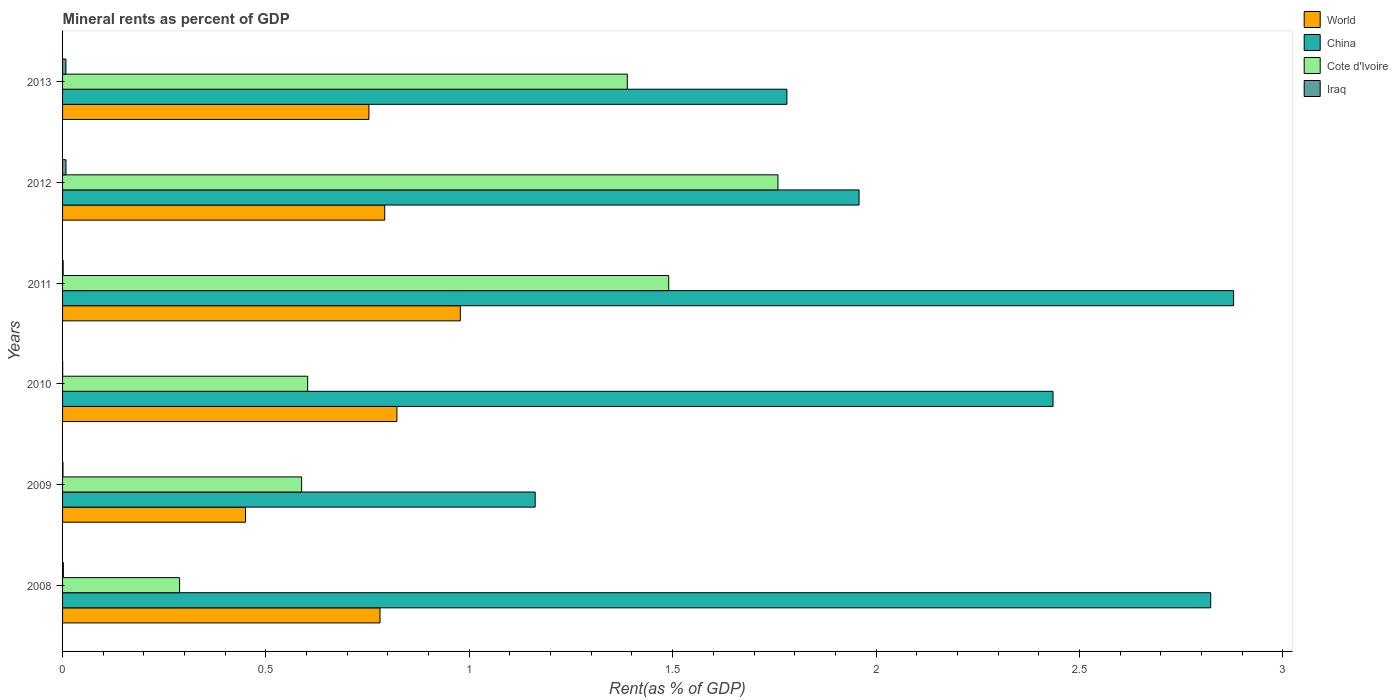What is the label of the 4th group of bars from the top?
Offer a terse response. 2010. In how many cases, is the number of bars for a given year not equal to the number of legend labels?
Provide a short and direct response. 0. What is the mineral rent in China in 2011?
Provide a succinct answer. 2.88. Across all years, what is the maximum mineral rent in Cote d'Ivoire?
Make the answer very short. 1.76. Across all years, what is the minimum mineral rent in Cote d'Ivoire?
Your answer should be compact. 0.29. In which year was the mineral rent in China maximum?
Keep it short and to the point. 2011. In which year was the mineral rent in China minimum?
Your response must be concise. 2009. What is the total mineral rent in Cote d'Ivoire in the graph?
Offer a terse response. 6.12. What is the difference between the mineral rent in China in 2010 and that in 2013?
Offer a very short reply. 0.65. What is the difference between the mineral rent in World in 2010 and the mineral rent in China in 2012?
Provide a succinct answer. -1.14. What is the average mineral rent in Cote d'Ivoire per year?
Provide a succinct answer. 1.02. In the year 2012, what is the difference between the mineral rent in World and mineral rent in Cote d'Ivoire?
Make the answer very short. -0.97. What is the ratio of the mineral rent in World in 2009 to that in 2010?
Provide a short and direct response. 0.55. What is the difference between the highest and the second highest mineral rent in World?
Give a very brief answer. 0.16. What is the difference between the highest and the lowest mineral rent in China?
Provide a short and direct response. 1.72. Is it the case that in every year, the sum of the mineral rent in World and mineral rent in China is greater than the sum of mineral rent in Iraq and mineral rent in Cote d'Ivoire?
Give a very brief answer. No. What does the 1st bar from the top in 2009 represents?
Offer a very short reply. Iraq. What does the 3rd bar from the bottom in 2010 represents?
Your answer should be compact. Cote d'Ivoire. Is it the case that in every year, the sum of the mineral rent in Cote d'Ivoire and mineral rent in World is greater than the mineral rent in Iraq?
Your answer should be compact. Yes. Are all the bars in the graph horizontal?
Ensure brevity in your answer.  Yes. How many years are there in the graph?
Ensure brevity in your answer.  6. Does the graph contain any zero values?
Give a very brief answer. No. Where does the legend appear in the graph?
Provide a short and direct response. Top right. How are the legend labels stacked?
Provide a succinct answer. Vertical. What is the title of the graph?
Ensure brevity in your answer.  Mineral rents as percent of GDP. Does "Pakistan" appear as one of the legend labels in the graph?
Keep it short and to the point. No. What is the label or title of the X-axis?
Ensure brevity in your answer.  Rent(as % of GDP). What is the label or title of the Y-axis?
Offer a very short reply. Years. What is the Rent(as % of GDP) in World in 2008?
Your response must be concise. 0.78. What is the Rent(as % of GDP) of China in 2008?
Ensure brevity in your answer.  2.82. What is the Rent(as % of GDP) in Cote d'Ivoire in 2008?
Ensure brevity in your answer.  0.29. What is the Rent(as % of GDP) of Iraq in 2008?
Ensure brevity in your answer.  0. What is the Rent(as % of GDP) of World in 2009?
Give a very brief answer. 0.45. What is the Rent(as % of GDP) of China in 2009?
Make the answer very short. 1.16. What is the Rent(as % of GDP) in Cote d'Ivoire in 2009?
Offer a terse response. 0.59. What is the Rent(as % of GDP) of Iraq in 2009?
Offer a very short reply. 0. What is the Rent(as % of GDP) of World in 2010?
Offer a very short reply. 0.82. What is the Rent(as % of GDP) of China in 2010?
Your response must be concise. 2.44. What is the Rent(as % of GDP) of Cote d'Ivoire in 2010?
Ensure brevity in your answer.  0.6. What is the Rent(as % of GDP) of Iraq in 2010?
Your response must be concise. 0. What is the Rent(as % of GDP) in World in 2011?
Your answer should be very brief. 0.98. What is the Rent(as % of GDP) in China in 2011?
Offer a terse response. 2.88. What is the Rent(as % of GDP) of Cote d'Ivoire in 2011?
Ensure brevity in your answer.  1.49. What is the Rent(as % of GDP) in Iraq in 2011?
Provide a short and direct response. 0. What is the Rent(as % of GDP) in World in 2012?
Ensure brevity in your answer.  0.79. What is the Rent(as % of GDP) in China in 2012?
Make the answer very short. 1.96. What is the Rent(as % of GDP) in Cote d'Ivoire in 2012?
Provide a succinct answer. 1.76. What is the Rent(as % of GDP) in Iraq in 2012?
Give a very brief answer. 0.01. What is the Rent(as % of GDP) in World in 2013?
Offer a terse response. 0.75. What is the Rent(as % of GDP) in China in 2013?
Provide a short and direct response. 1.78. What is the Rent(as % of GDP) in Cote d'Ivoire in 2013?
Your answer should be very brief. 1.39. What is the Rent(as % of GDP) of Iraq in 2013?
Keep it short and to the point. 0.01. Across all years, what is the maximum Rent(as % of GDP) in World?
Your answer should be very brief. 0.98. Across all years, what is the maximum Rent(as % of GDP) in China?
Offer a terse response. 2.88. Across all years, what is the maximum Rent(as % of GDP) of Cote d'Ivoire?
Provide a short and direct response. 1.76. Across all years, what is the maximum Rent(as % of GDP) in Iraq?
Offer a terse response. 0.01. Across all years, what is the minimum Rent(as % of GDP) in World?
Provide a short and direct response. 0.45. Across all years, what is the minimum Rent(as % of GDP) in China?
Make the answer very short. 1.16. Across all years, what is the minimum Rent(as % of GDP) of Cote d'Ivoire?
Offer a terse response. 0.29. Across all years, what is the minimum Rent(as % of GDP) of Iraq?
Your answer should be very brief. 0. What is the total Rent(as % of GDP) of World in the graph?
Keep it short and to the point. 4.58. What is the total Rent(as % of GDP) in China in the graph?
Your response must be concise. 13.04. What is the total Rent(as % of GDP) of Cote d'Ivoire in the graph?
Keep it short and to the point. 6.12. What is the total Rent(as % of GDP) in Iraq in the graph?
Make the answer very short. 0.02. What is the difference between the Rent(as % of GDP) of World in 2008 and that in 2009?
Keep it short and to the point. 0.33. What is the difference between the Rent(as % of GDP) in China in 2008 and that in 2009?
Keep it short and to the point. 1.66. What is the difference between the Rent(as % of GDP) of Iraq in 2008 and that in 2009?
Make the answer very short. 0. What is the difference between the Rent(as % of GDP) in World in 2008 and that in 2010?
Offer a very short reply. -0.04. What is the difference between the Rent(as % of GDP) of China in 2008 and that in 2010?
Provide a short and direct response. 0.39. What is the difference between the Rent(as % of GDP) of Cote d'Ivoire in 2008 and that in 2010?
Make the answer very short. -0.31. What is the difference between the Rent(as % of GDP) in Iraq in 2008 and that in 2010?
Make the answer very short. 0. What is the difference between the Rent(as % of GDP) of World in 2008 and that in 2011?
Keep it short and to the point. -0.2. What is the difference between the Rent(as % of GDP) in China in 2008 and that in 2011?
Your answer should be very brief. -0.06. What is the difference between the Rent(as % of GDP) of Cote d'Ivoire in 2008 and that in 2011?
Provide a short and direct response. -1.2. What is the difference between the Rent(as % of GDP) of World in 2008 and that in 2012?
Give a very brief answer. -0.01. What is the difference between the Rent(as % of GDP) in China in 2008 and that in 2012?
Give a very brief answer. 0.86. What is the difference between the Rent(as % of GDP) of Cote d'Ivoire in 2008 and that in 2012?
Provide a short and direct response. -1.47. What is the difference between the Rent(as % of GDP) in Iraq in 2008 and that in 2012?
Give a very brief answer. -0.01. What is the difference between the Rent(as % of GDP) of World in 2008 and that in 2013?
Offer a very short reply. 0.03. What is the difference between the Rent(as % of GDP) of China in 2008 and that in 2013?
Offer a very short reply. 1.04. What is the difference between the Rent(as % of GDP) of Cote d'Ivoire in 2008 and that in 2013?
Your response must be concise. -1.1. What is the difference between the Rent(as % of GDP) of Iraq in 2008 and that in 2013?
Offer a very short reply. -0.01. What is the difference between the Rent(as % of GDP) of World in 2009 and that in 2010?
Provide a succinct answer. -0.37. What is the difference between the Rent(as % of GDP) of China in 2009 and that in 2010?
Your answer should be very brief. -1.27. What is the difference between the Rent(as % of GDP) of Cote d'Ivoire in 2009 and that in 2010?
Keep it short and to the point. -0.01. What is the difference between the Rent(as % of GDP) of Iraq in 2009 and that in 2010?
Offer a terse response. 0. What is the difference between the Rent(as % of GDP) in World in 2009 and that in 2011?
Keep it short and to the point. -0.53. What is the difference between the Rent(as % of GDP) in China in 2009 and that in 2011?
Your answer should be very brief. -1.72. What is the difference between the Rent(as % of GDP) of Cote d'Ivoire in 2009 and that in 2011?
Your response must be concise. -0.9. What is the difference between the Rent(as % of GDP) in Iraq in 2009 and that in 2011?
Ensure brevity in your answer.  -0. What is the difference between the Rent(as % of GDP) of World in 2009 and that in 2012?
Make the answer very short. -0.34. What is the difference between the Rent(as % of GDP) of China in 2009 and that in 2012?
Give a very brief answer. -0.8. What is the difference between the Rent(as % of GDP) in Cote d'Ivoire in 2009 and that in 2012?
Make the answer very short. -1.17. What is the difference between the Rent(as % of GDP) in Iraq in 2009 and that in 2012?
Offer a very short reply. -0.01. What is the difference between the Rent(as % of GDP) in World in 2009 and that in 2013?
Provide a short and direct response. -0.3. What is the difference between the Rent(as % of GDP) in China in 2009 and that in 2013?
Your response must be concise. -0.62. What is the difference between the Rent(as % of GDP) in Cote d'Ivoire in 2009 and that in 2013?
Ensure brevity in your answer.  -0.8. What is the difference between the Rent(as % of GDP) of Iraq in 2009 and that in 2013?
Your response must be concise. -0.01. What is the difference between the Rent(as % of GDP) in World in 2010 and that in 2011?
Ensure brevity in your answer.  -0.16. What is the difference between the Rent(as % of GDP) of China in 2010 and that in 2011?
Your answer should be very brief. -0.44. What is the difference between the Rent(as % of GDP) in Cote d'Ivoire in 2010 and that in 2011?
Give a very brief answer. -0.89. What is the difference between the Rent(as % of GDP) of Iraq in 2010 and that in 2011?
Keep it short and to the point. -0. What is the difference between the Rent(as % of GDP) in China in 2010 and that in 2012?
Offer a very short reply. 0.48. What is the difference between the Rent(as % of GDP) of Cote d'Ivoire in 2010 and that in 2012?
Keep it short and to the point. -1.16. What is the difference between the Rent(as % of GDP) of Iraq in 2010 and that in 2012?
Keep it short and to the point. -0.01. What is the difference between the Rent(as % of GDP) of World in 2010 and that in 2013?
Provide a succinct answer. 0.07. What is the difference between the Rent(as % of GDP) of China in 2010 and that in 2013?
Your answer should be very brief. 0.65. What is the difference between the Rent(as % of GDP) in Cote d'Ivoire in 2010 and that in 2013?
Offer a very short reply. -0.79. What is the difference between the Rent(as % of GDP) of Iraq in 2010 and that in 2013?
Your answer should be very brief. -0.01. What is the difference between the Rent(as % of GDP) of World in 2011 and that in 2012?
Give a very brief answer. 0.19. What is the difference between the Rent(as % of GDP) in China in 2011 and that in 2012?
Give a very brief answer. 0.92. What is the difference between the Rent(as % of GDP) in Cote d'Ivoire in 2011 and that in 2012?
Your response must be concise. -0.27. What is the difference between the Rent(as % of GDP) of Iraq in 2011 and that in 2012?
Ensure brevity in your answer.  -0.01. What is the difference between the Rent(as % of GDP) of World in 2011 and that in 2013?
Your answer should be very brief. 0.22. What is the difference between the Rent(as % of GDP) in China in 2011 and that in 2013?
Ensure brevity in your answer.  1.1. What is the difference between the Rent(as % of GDP) of Cote d'Ivoire in 2011 and that in 2013?
Offer a terse response. 0.1. What is the difference between the Rent(as % of GDP) in Iraq in 2011 and that in 2013?
Make the answer very short. -0.01. What is the difference between the Rent(as % of GDP) in World in 2012 and that in 2013?
Your answer should be compact. 0.04. What is the difference between the Rent(as % of GDP) in China in 2012 and that in 2013?
Your answer should be compact. 0.18. What is the difference between the Rent(as % of GDP) of Cote d'Ivoire in 2012 and that in 2013?
Make the answer very short. 0.37. What is the difference between the Rent(as % of GDP) of World in 2008 and the Rent(as % of GDP) of China in 2009?
Your answer should be very brief. -0.38. What is the difference between the Rent(as % of GDP) in World in 2008 and the Rent(as % of GDP) in Cote d'Ivoire in 2009?
Offer a very short reply. 0.19. What is the difference between the Rent(as % of GDP) of World in 2008 and the Rent(as % of GDP) of Iraq in 2009?
Keep it short and to the point. 0.78. What is the difference between the Rent(as % of GDP) of China in 2008 and the Rent(as % of GDP) of Cote d'Ivoire in 2009?
Provide a short and direct response. 2.24. What is the difference between the Rent(as % of GDP) in China in 2008 and the Rent(as % of GDP) in Iraq in 2009?
Make the answer very short. 2.82. What is the difference between the Rent(as % of GDP) of Cote d'Ivoire in 2008 and the Rent(as % of GDP) of Iraq in 2009?
Your answer should be compact. 0.29. What is the difference between the Rent(as % of GDP) in World in 2008 and the Rent(as % of GDP) in China in 2010?
Your answer should be compact. -1.65. What is the difference between the Rent(as % of GDP) in World in 2008 and the Rent(as % of GDP) in Cote d'Ivoire in 2010?
Your answer should be very brief. 0.18. What is the difference between the Rent(as % of GDP) of World in 2008 and the Rent(as % of GDP) of Iraq in 2010?
Your answer should be compact. 0.78. What is the difference between the Rent(as % of GDP) of China in 2008 and the Rent(as % of GDP) of Cote d'Ivoire in 2010?
Make the answer very short. 2.22. What is the difference between the Rent(as % of GDP) in China in 2008 and the Rent(as % of GDP) in Iraq in 2010?
Your response must be concise. 2.82. What is the difference between the Rent(as % of GDP) of Cote d'Ivoire in 2008 and the Rent(as % of GDP) of Iraq in 2010?
Provide a succinct answer. 0.29. What is the difference between the Rent(as % of GDP) in World in 2008 and the Rent(as % of GDP) in China in 2011?
Give a very brief answer. -2.1. What is the difference between the Rent(as % of GDP) of World in 2008 and the Rent(as % of GDP) of Cote d'Ivoire in 2011?
Offer a very short reply. -0.71. What is the difference between the Rent(as % of GDP) in World in 2008 and the Rent(as % of GDP) in Iraq in 2011?
Provide a short and direct response. 0.78. What is the difference between the Rent(as % of GDP) of China in 2008 and the Rent(as % of GDP) of Cote d'Ivoire in 2011?
Your answer should be compact. 1.33. What is the difference between the Rent(as % of GDP) of China in 2008 and the Rent(as % of GDP) of Iraq in 2011?
Your response must be concise. 2.82. What is the difference between the Rent(as % of GDP) in Cote d'Ivoire in 2008 and the Rent(as % of GDP) in Iraq in 2011?
Offer a terse response. 0.29. What is the difference between the Rent(as % of GDP) in World in 2008 and the Rent(as % of GDP) in China in 2012?
Ensure brevity in your answer.  -1.18. What is the difference between the Rent(as % of GDP) of World in 2008 and the Rent(as % of GDP) of Cote d'Ivoire in 2012?
Your answer should be compact. -0.98. What is the difference between the Rent(as % of GDP) of World in 2008 and the Rent(as % of GDP) of Iraq in 2012?
Make the answer very short. 0.77. What is the difference between the Rent(as % of GDP) in China in 2008 and the Rent(as % of GDP) in Cote d'Ivoire in 2012?
Offer a very short reply. 1.06. What is the difference between the Rent(as % of GDP) in China in 2008 and the Rent(as % of GDP) in Iraq in 2012?
Your response must be concise. 2.81. What is the difference between the Rent(as % of GDP) of Cote d'Ivoire in 2008 and the Rent(as % of GDP) of Iraq in 2012?
Make the answer very short. 0.28. What is the difference between the Rent(as % of GDP) of World in 2008 and the Rent(as % of GDP) of China in 2013?
Provide a succinct answer. -1. What is the difference between the Rent(as % of GDP) of World in 2008 and the Rent(as % of GDP) of Cote d'Ivoire in 2013?
Your answer should be very brief. -0.61. What is the difference between the Rent(as % of GDP) of World in 2008 and the Rent(as % of GDP) of Iraq in 2013?
Make the answer very short. 0.77. What is the difference between the Rent(as % of GDP) in China in 2008 and the Rent(as % of GDP) in Cote d'Ivoire in 2013?
Provide a succinct answer. 1.43. What is the difference between the Rent(as % of GDP) in China in 2008 and the Rent(as % of GDP) in Iraq in 2013?
Ensure brevity in your answer.  2.81. What is the difference between the Rent(as % of GDP) in Cote d'Ivoire in 2008 and the Rent(as % of GDP) in Iraq in 2013?
Offer a very short reply. 0.28. What is the difference between the Rent(as % of GDP) in World in 2009 and the Rent(as % of GDP) in China in 2010?
Offer a very short reply. -1.99. What is the difference between the Rent(as % of GDP) in World in 2009 and the Rent(as % of GDP) in Cote d'Ivoire in 2010?
Offer a very short reply. -0.15. What is the difference between the Rent(as % of GDP) in World in 2009 and the Rent(as % of GDP) in Iraq in 2010?
Offer a very short reply. 0.45. What is the difference between the Rent(as % of GDP) in China in 2009 and the Rent(as % of GDP) in Cote d'Ivoire in 2010?
Provide a short and direct response. 0.56. What is the difference between the Rent(as % of GDP) in China in 2009 and the Rent(as % of GDP) in Iraq in 2010?
Your response must be concise. 1.16. What is the difference between the Rent(as % of GDP) of Cote d'Ivoire in 2009 and the Rent(as % of GDP) of Iraq in 2010?
Offer a very short reply. 0.59. What is the difference between the Rent(as % of GDP) of World in 2009 and the Rent(as % of GDP) of China in 2011?
Ensure brevity in your answer.  -2.43. What is the difference between the Rent(as % of GDP) in World in 2009 and the Rent(as % of GDP) in Cote d'Ivoire in 2011?
Your answer should be very brief. -1.04. What is the difference between the Rent(as % of GDP) of World in 2009 and the Rent(as % of GDP) of Iraq in 2011?
Provide a short and direct response. 0.45. What is the difference between the Rent(as % of GDP) of China in 2009 and the Rent(as % of GDP) of Cote d'Ivoire in 2011?
Provide a succinct answer. -0.33. What is the difference between the Rent(as % of GDP) in China in 2009 and the Rent(as % of GDP) in Iraq in 2011?
Make the answer very short. 1.16. What is the difference between the Rent(as % of GDP) in Cote d'Ivoire in 2009 and the Rent(as % of GDP) in Iraq in 2011?
Offer a very short reply. 0.59. What is the difference between the Rent(as % of GDP) in World in 2009 and the Rent(as % of GDP) in China in 2012?
Your answer should be compact. -1.51. What is the difference between the Rent(as % of GDP) of World in 2009 and the Rent(as % of GDP) of Cote d'Ivoire in 2012?
Ensure brevity in your answer.  -1.31. What is the difference between the Rent(as % of GDP) in World in 2009 and the Rent(as % of GDP) in Iraq in 2012?
Offer a terse response. 0.44. What is the difference between the Rent(as % of GDP) in China in 2009 and the Rent(as % of GDP) in Cote d'Ivoire in 2012?
Provide a short and direct response. -0.6. What is the difference between the Rent(as % of GDP) in China in 2009 and the Rent(as % of GDP) in Iraq in 2012?
Ensure brevity in your answer.  1.15. What is the difference between the Rent(as % of GDP) of Cote d'Ivoire in 2009 and the Rent(as % of GDP) of Iraq in 2012?
Your answer should be compact. 0.58. What is the difference between the Rent(as % of GDP) in World in 2009 and the Rent(as % of GDP) in China in 2013?
Your answer should be compact. -1.33. What is the difference between the Rent(as % of GDP) in World in 2009 and the Rent(as % of GDP) in Cote d'Ivoire in 2013?
Your answer should be very brief. -0.94. What is the difference between the Rent(as % of GDP) in World in 2009 and the Rent(as % of GDP) in Iraq in 2013?
Offer a terse response. 0.44. What is the difference between the Rent(as % of GDP) in China in 2009 and the Rent(as % of GDP) in Cote d'Ivoire in 2013?
Provide a short and direct response. -0.23. What is the difference between the Rent(as % of GDP) in China in 2009 and the Rent(as % of GDP) in Iraq in 2013?
Your response must be concise. 1.15. What is the difference between the Rent(as % of GDP) in Cote d'Ivoire in 2009 and the Rent(as % of GDP) in Iraq in 2013?
Provide a succinct answer. 0.58. What is the difference between the Rent(as % of GDP) in World in 2010 and the Rent(as % of GDP) in China in 2011?
Your answer should be compact. -2.06. What is the difference between the Rent(as % of GDP) of World in 2010 and the Rent(as % of GDP) of Cote d'Ivoire in 2011?
Provide a short and direct response. -0.67. What is the difference between the Rent(as % of GDP) of World in 2010 and the Rent(as % of GDP) of Iraq in 2011?
Keep it short and to the point. 0.82. What is the difference between the Rent(as % of GDP) of China in 2010 and the Rent(as % of GDP) of Cote d'Ivoire in 2011?
Your answer should be very brief. 0.94. What is the difference between the Rent(as % of GDP) of China in 2010 and the Rent(as % of GDP) of Iraq in 2011?
Ensure brevity in your answer.  2.43. What is the difference between the Rent(as % of GDP) in Cote d'Ivoire in 2010 and the Rent(as % of GDP) in Iraq in 2011?
Offer a terse response. 0.6. What is the difference between the Rent(as % of GDP) in World in 2010 and the Rent(as % of GDP) in China in 2012?
Provide a short and direct response. -1.14. What is the difference between the Rent(as % of GDP) of World in 2010 and the Rent(as % of GDP) of Cote d'Ivoire in 2012?
Your response must be concise. -0.94. What is the difference between the Rent(as % of GDP) of World in 2010 and the Rent(as % of GDP) of Iraq in 2012?
Your response must be concise. 0.81. What is the difference between the Rent(as % of GDP) in China in 2010 and the Rent(as % of GDP) in Cote d'Ivoire in 2012?
Ensure brevity in your answer.  0.68. What is the difference between the Rent(as % of GDP) in China in 2010 and the Rent(as % of GDP) in Iraq in 2012?
Make the answer very short. 2.43. What is the difference between the Rent(as % of GDP) of Cote d'Ivoire in 2010 and the Rent(as % of GDP) of Iraq in 2012?
Your answer should be compact. 0.59. What is the difference between the Rent(as % of GDP) of World in 2010 and the Rent(as % of GDP) of China in 2013?
Your response must be concise. -0.96. What is the difference between the Rent(as % of GDP) of World in 2010 and the Rent(as % of GDP) of Cote d'Ivoire in 2013?
Your answer should be compact. -0.57. What is the difference between the Rent(as % of GDP) in World in 2010 and the Rent(as % of GDP) in Iraq in 2013?
Offer a terse response. 0.81. What is the difference between the Rent(as % of GDP) of China in 2010 and the Rent(as % of GDP) of Cote d'Ivoire in 2013?
Make the answer very short. 1.05. What is the difference between the Rent(as % of GDP) in China in 2010 and the Rent(as % of GDP) in Iraq in 2013?
Keep it short and to the point. 2.43. What is the difference between the Rent(as % of GDP) in Cote d'Ivoire in 2010 and the Rent(as % of GDP) in Iraq in 2013?
Your answer should be compact. 0.59. What is the difference between the Rent(as % of GDP) of World in 2011 and the Rent(as % of GDP) of China in 2012?
Provide a short and direct response. -0.98. What is the difference between the Rent(as % of GDP) of World in 2011 and the Rent(as % of GDP) of Cote d'Ivoire in 2012?
Ensure brevity in your answer.  -0.78. What is the difference between the Rent(as % of GDP) of World in 2011 and the Rent(as % of GDP) of Iraq in 2012?
Your answer should be very brief. 0.97. What is the difference between the Rent(as % of GDP) in China in 2011 and the Rent(as % of GDP) in Cote d'Ivoire in 2012?
Provide a short and direct response. 1.12. What is the difference between the Rent(as % of GDP) of China in 2011 and the Rent(as % of GDP) of Iraq in 2012?
Provide a short and direct response. 2.87. What is the difference between the Rent(as % of GDP) in Cote d'Ivoire in 2011 and the Rent(as % of GDP) in Iraq in 2012?
Provide a short and direct response. 1.48. What is the difference between the Rent(as % of GDP) of World in 2011 and the Rent(as % of GDP) of China in 2013?
Keep it short and to the point. -0.8. What is the difference between the Rent(as % of GDP) of World in 2011 and the Rent(as % of GDP) of Cote d'Ivoire in 2013?
Provide a short and direct response. -0.41. What is the difference between the Rent(as % of GDP) in World in 2011 and the Rent(as % of GDP) in Iraq in 2013?
Your answer should be very brief. 0.97. What is the difference between the Rent(as % of GDP) in China in 2011 and the Rent(as % of GDP) in Cote d'Ivoire in 2013?
Ensure brevity in your answer.  1.49. What is the difference between the Rent(as % of GDP) of China in 2011 and the Rent(as % of GDP) of Iraq in 2013?
Your answer should be very brief. 2.87. What is the difference between the Rent(as % of GDP) of Cote d'Ivoire in 2011 and the Rent(as % of GDP) of Iraq in 2013?
Give a very brief answer. 1.48. What is the difference between the Rent(as % of GDP) of World in 2012 and the Rent(as % of GDP) of China in 2013?
Keep it short and to the point. -0.99. What is the difference between the Rent(as % of GDP) in World in 2012 and the Rent(as % of GDP) in Cote d'Ivoire in 2013?
Offer a terse response. -0.6. What is the difference between the Rent(as % of GDP) in World in 2012 and the Rent(as % of GDP) in Iraq in 2013?
Ensure brevity in your answer.  0.78. What is the difference between the Rent(as % of GDP) of China in 2012 and the Rent(as % of GDP) of Cote d'Ivoire in 2013?
Your answer should be compact. 0.57. What is the difference between the Rent(as % of GDP) of China in 2012 and the Rent(as % of GDP) of Iraq in 2013?
Provide a succinct answer. 1.95. What is the difference between the Rent(as % of GDP) of Cote d'Ivoire in 2012 and the Rent(as % of GDP) of Iraq in 2013?
Provide a short and direct response. 1.75. What is the average Rent(as % of GDP) in World per year?
Make the answer very short. 0.76. What is the average Rent(as % of GDP) in China per year?
Make the answer very short. 2.17. What is the average Rent(as % of GDP) in Cote d'Ivoire per year?
Your answer should be compact. 1.02. What is the average Rent(as % of GDP) in Iraq per year?
Your answer should be compact. 0. In the year 2008, what is the difference between the Rent(as % of GDP) in World and Rent(as % of GDP) in China?
Ensure brevity in your answer.  -2.04. In the year 2008, what is the difference between the Rent(as % of GDP) of World and Rent(as % of GDP) of Cote d'Ivoire?
Provide a succinct answer. 0.49. In the year 2008, what is the difference between the Rent(as % of GDP) in World and Rent(as % of GDP) in Iraq?
Your answer should be very brief. 0.78. In the year 2008, what is the difference between the Rent(as % of GDP) of China and Rent(as % of GDP) of Cote d'Ivoire?
Offer a very short reply. 2.54. In the year 2008, what is the difference between the Rent(as % of GDP) in China and Rent(as % of GDP) in Iraq?
Keep it short and to the point. 2.82. In the year 2008, what is the difference between the Rent(as % of GDP) in Cote d'Ivoire and Rent(as % of GDP) in Iraq?
Give a very brief answer. 0.29. In the year 2009, what is the difference between the Rent(as % of GDP) in World and Rent(as % of GDP) in China?
Offer a very short reply. -0.71. In the year 2009, what is the difference between the Rent(as % of GDP) of World and Rent(as % of GDP) of Cote d'Ivoire?
Keep it short and to the point. -0.14. In the year 2009, what is the difference between the Rent(as % of GDP) of World and Rent(as % of GDP) of Iraq?
Make the answer very short. 0.45. In the year 2009, what is the difference between the Rent(as % of GDP) of China and Rent(as % of GDP) of Cote d'Ivoire?
Provide a succinct answer. 0.57. In the year 2009, what is the difference between the Rent(as % of GDP) in China and Rent(as % of GDP) in Iraq?
Provide a succinct answer. 1.16. In the year 2009, what is the difference between the Rent(as % of GDP) in Cote d'Ivoire and Rent(as % of GDP) in Iraq?
Offer a very short reply. 0.59. In the year 2010, what is the difference between the Rent(as % of GDP) in World and Rent(as % of GDP) in China?
Your answer should be compact. -1.61. In the year 2010, what is the difference between the Rent(as % of GDP) of World and Rent(as % of GDP) of Cote d'Ivoire?
Give a very brief answer. 0.22. In the year 2010, what is the difference between the Rent(as % of GDP) in World and Rent(as % of GDP) in Iraq?
Provide a short and direct response. 0.82. In the year 2010, what is the difference between the Rent(as % of GDP) in China and Rent(as % of GDP) in Cote d'Ivoire?
Keep it short and to the point. 1.83. In the year 2010, what is the difference between the Rent(as % of GDP) of China and Rent(as % of GDP) of Iraq?
Keep it short and to the point. 2.43. In the year 2010, what is the difference between the Rent(as % of GDP) of Cote d'Ivoire and Rent(as % of GDP) of Iraq?
Offer a very short reply. 0.6. In the year 2011, what is the difference between the Rent(as % of GDP) in World and Rent(as % of GDP) in China?
Give a very brief answer. -1.9. In the year 2011, what is the difference between the Rent(as % of GDP) of World and Rent(as % of GDP) of Cote d'Ivoire?
Your answer should be compact. -0.51. In the year 2011, what is the difference between the Rent(as % of GDP) in World and Rent(as % of GDP) in Iraq?
Provide a succinct answer. 0.98. In the year 2011, what is the difference between the Rent(as % of GDP) of China and Rent(as % of GDP) of Cote d'Ivoire?
Your answer should be very brief. 1.39. In the year 2011, what is the difference between the Rent(as % of GDP) of China and Rent(as % of GDP) of Iraq?
Offer a terse response. 2.88. In the year 2011, what is the difference between the Rent(as % of GDP) in Cote d'Ivoire and Rent(as % of GDP) in Iraq?
Provide a short and direct response. 1.49. In the year 2012, what is the difference between the Rent(as % of GDP) of World and Rent(as % of GDP) of China?
Provide a succinct answer. -1.17. In the year 2012, what is the difference between the Rent(as % of GDP) in World and Rent(as % of GDP) in Cote d'Ivoire?
Provide a short and direct response. -0.97. In the year 2012, what is the difference between the Rent(as % of GDP) of World and Rent(as % of GDP) of Iraq?
Keep it short and to the point. 0.78. In the year 2012, what is the difference between the Rent(as % of GDP) in China and Rent(as % of GDP) in Cote d'Ivoire?
Make the answer very short. 0.2. In the year 2012, what is the difference between the Rent(as % of GDP) of China and Rent(as % of GDP) of Iraq?
Provide a short and direct response. 1.95. In the year 2012, what is the difference between the Rent(as % of GDP) in Cote d'Ivoire and Rent(as % of GDP) in Iraq?
Give a very brief answer. 1.75. In the year 2013, what is the difference between the Rent(as % of GDP) in World and Rent(as % of GDP) in China?
Your answer should be compact. -1.03. In the year 2013, what is the difference between the Rent(as % of GDP) of World and Rent(as % of GDP) of Cote d'Ivoire?
Offer a very short reply. -0.64. In the year 2013, what is the difference between the Rent(as % of GDP) of World and Rent(as % of GDP) of Iraq?
Keep it short and to the point. 0.74. In the year 2013, what is the difference between the Rent(as % of GDP) of China and Rent(as % of GDP) of Cote d'Ivoire?
Your answer should be compact. 0.39. In the year 2013, what is the difference between the Rent(as % of GDP) of China and Rent(as % of GDP) of Iraq?
Your response must be concise. 1.77. In the year 2013, what is the difference between the Rent(as % of GDP) in Cote d'Ivoire and Rent(as % of GDP) in Iraq?
Provide a short and direct response. 1.38. What is the ratio of the Rent(as % of GDP) of World in 2008 to that in 2009?
Your response must be concise. 1.74. What is the ratio of the Rent(as % of GDP) in China in 2008 to that in 2009?
Your answer should be compact. 2.43. What is the ratio of the Rent(as % of GDP) of Cote d'Ivoire in 2008 to that in 2009?
Make the answer very short. 0.49. What is the ratio of the Rent(as % of GDP) of Iraq in 2008 to that in 2009?
Ensure brevity in your answer.  1.95. What is the ratio of the Rent(as % of GDP) in World in 2008 to that in 2010?
Provide a succinct answer. 0.95. What is the ratio of the Rent(as % of GDP) in China in 2008 to that in 2010?
Offer a very short reply. 1.16. What is the ratio of the Rent(as % of GDP) in Cote d'Ivoire in 2008 to that in 2010?
Keep it short and to the point. 0.48. What is the ratio of the Rent(as % of GDP) in Iraq in 2008 to that in 2010?
Your response must be concise. 7.63. What is the ratio of the Rent(as % of GDP) in World in 2008 to that in 2011?
Provide a succinct answer. 0.8. What is the ratio of the Rent(as % of GDP) of China in 2008 to that in 2011?
Your answer should be compact. 0.98. What is the ratio of the Rent(as % of GDP) in Cote d'Ivoire in 2008 to that in 2011?
Make the answer very short. 0.19. What is the ratio of the Rent(as % of GDP) of Iraq in 2008 to that in 2011?
Offer a very short reply. 1.35. What is the ratio of the Rent(as % of GDP) of World in 2008 to that in 2012?
Make the answer very short. 0.99. What is the ratio of the Rent(as % of GDP) in China in 2008 to that in 2012?
Make the answer very short. 1.44. What is the ratio of the Rent(as % of GDP) of Cote d'Ivoire in 2008 to that in 2012?
Give a very brief answer. 0.16. What is the ratio of the Rent(as % of GDP) of Iraq in 2008 to that in 2012?
Keep it short and to the point. 0.23. What is the ratio of the Rent(as % of GDP) of World in 2008 to that in 2013?
Your answer should be very brief. 1.04. What is the ratio of the Rent(as % of GDP) in China in 2008 to that in 2013?
Offer a terse response. 1.59. What is the ratio of the Rent(as % of GDP) of Cote d'Ivoire in 2008 to that in 2013?
Offer a very short reply. 0.21. What is the ratio of the Rent(as % of GDP) of Iraq in 2008 to that in 2013?
Offer a terse response. 0.23. What is the ratio of the Rent(as % of GDP) of World in 2009 to that in 2010?
Provide a short and direct response. 0.55. What is the ratio of the Rent(as % of GDP) of China in 2009 to that in 2010?
Make the answer very short. 0.48. What is the ratio of the Rent(as % of GDP) in Cote d'Ivoire in 2009 to that in 2010?
Your answer should be very brief. 0.98. What is the ratio of the Rent(as % of GDP) in Iraq in 2009 to that in 2010?
Keep it short and to the point. 3.91. What is the ratio of the Rent(as % of GDP) of World in 2009 to that in 2011?
Your answer should be compact. 0.46. What is the ratio of the Rent(as % of GDP) of China in 2009 to that in 2011?
Ensure brevity in your answer.  0.4. What is the ratio of the Rent(as % of GDP) in Cote d'Ivoire in 2009 to that in 2011?
Your answer should be compact. 0.39. What is the ratio of the Rent(as % of GDP) in Iraq in 2009 to that in 2011?
Give a very brief answer. 0.69. What is the ratio of the Rent(as % of GDP) of World in 2009 to that in 2012?
Your answer should be compact. 0.57. What is the ratio of the Rent(as % of GDP) of China in 2009 to that in 2012?
Provide a short and direct response. 0.59. What is the ratio of the Rent(as % of GDP) of Cote d'Ivoire in 2009 to that in 2012?
Offer a very short reply. 0.33. What is the ratio of the Rent(as % of GDP) in Iraq in 2009 to that in 2012?
Your answer should be very brief. 0.12. What is the ratio of the Rent(as % of GDP) in World in 2009 to that in 2013?
Offer a very short reply. 0.6. What is the ratio of the Rent(as % of GDP) in China in 2009 to that in 2013?
Offer a very short reply. 0.65. What is the ratio of the Rent(as % of GDP) in Cote d'Ivoire in 2009 to that in 2013?
Ensure brevity in your answer.  0.42. What is the ratio of the Rent(as % of GDP) of Iraq in 2009 to that in 2013?
Your answer should be very brief. 0.12. What is the ratio of the Rent(as % of GDP) in World in 2010 to that in 2011?
Offer a very short reply. 0.84. What is the ratio of the Rent(as % of GDP) in China in 2010 to that in 2011?
Provide a short and direct response. 0.85. What is the ratio of the Rent(as % of GDP) in Cote d'Ivoire in 2010 to that in 2011?
Offer a terse response. 0.4. What is the ratio of the Rent(as % of GDP) in Iraq in 2010 to that in 2011?
Your response must be concise. 0.18. What is the ratio of the Rent(as % of GDP) of World in 2010 to that in 2012?
Provide a short and direct response. 1.04. What is the ratio of the Rent(as % of GDP) in China in 2010 to that in 2012?
Your answer should be compact. 1.24. What is the ratio of the Rent(as % of GDP) of Cote d'Ivoire in 2010 to that in 2012?
Offer a very short reply. 0.34. What is the ratio of the Rent(as % of GDP) of Iraq in 2010 to that in 2012?
Make the answer very short. 0.03. What is the ratio of the Rent(as % of GDP) in World in 2010 to that in 2013?
Ensure brevity in your answer.  1.09. What is the ratio of the Rent(as % of GDP) of China in 2010 to that in 2013?
Keep it short and to the point. 1.37. What is the ratio of the Rent(as % of GDP) of Cote d'Ivoire in 2010 to that in 2013?
Ensure brevity in your answer.  0.43. What is the ratio of the Rent(as % of GDP) of Iraq in 2010 to that in 2013?
Your answer should be very brief. 0.03. What is the ratio of the Rent(as % of GDP) in World in 2011 to that in 2012?
Offer a very short reply. 1.23. What is the ratio of the Rent(as % of GDP) of China in 2011 to that in 2012?
Offer a very short reply. 1.47. What is the ratio of the Rent(as % of GDP) of Cote d'Ivoire in 2011 to that in 2012?
Ensure brevity in your answer.  0.85. What is the ratio of the Rent(as % of GDP) of Iraq in 2011 to that in 2012?
Offer a terse response. 0.17. What is the ratio of the Rent(as % of GDP) in World in 2011 to that in 2013?
Your answer should be compact. 1.3. What is the ratio of the Rent(as % of GDP) of China in 2011 to that in 2013?
Your answer should be very brief. 1.62. What is the ratio of the Rent(as % of GDP) in Cote d'Ivoire in 2011 to that in 2013?
Provide a succinct answer. 1.07. What is the ratio of the Rent(as % of GDP) of Iraq in 2011 to that in 2013?
Your answer should be compact. 0.17. What is the ratio of the Rent(as % of GDP) in World in 2012 to that in 2013?
Your response must be concise. 1.05. What is the ratio of the Rent(as % of GDP) in China in 2012 to that in 2013?
Your response must be concise. 1.1. What is the ratio of the Rent(as % of GDP) in Cote d'Ivoire in 2012 to that in 2013?
Provide a succinct answer. 1.27. What is the difference between the highest and the second highest Rent(as % of GDP) in World?
Offer a terse response. 0.16. What is the difference between the highest and the second highest Rent(as % of GDP) of China?
Offer a very short reply. 0.06. What is the difference between the highest and the second highest Rent(as % of GDP) of Cote d'Ivoire?
Provide a short and direct response. 0.27. What is the difference between the highest and the lowest Rent(as % of GDP) of World?
Offer a very short reply. 0.53. What is the difference between the highest and the lowest Rent(as % of GDP) in China?
Your answer should be very brief. 1.72. What is the difference between the highest and the lowest Rent(as % of GDP) of Cote d'Ivoire?
Make the answer very short. 1.47. What is the difference between the highest and the lowest Rent(as % of GDP) of Iraq?
Keep it short and to the point. 0.01. 